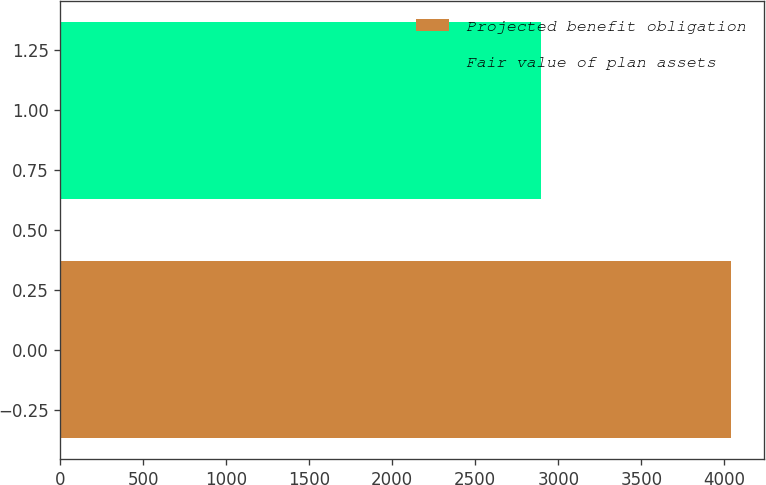<chart> <loc_0><loc_0><loc_500><loc_500><bar_chart><fcel>Projected benefit obligation<fcel>Fair value of plan assets<nl><fcel>4038<fcel>2897<nl></chart> 